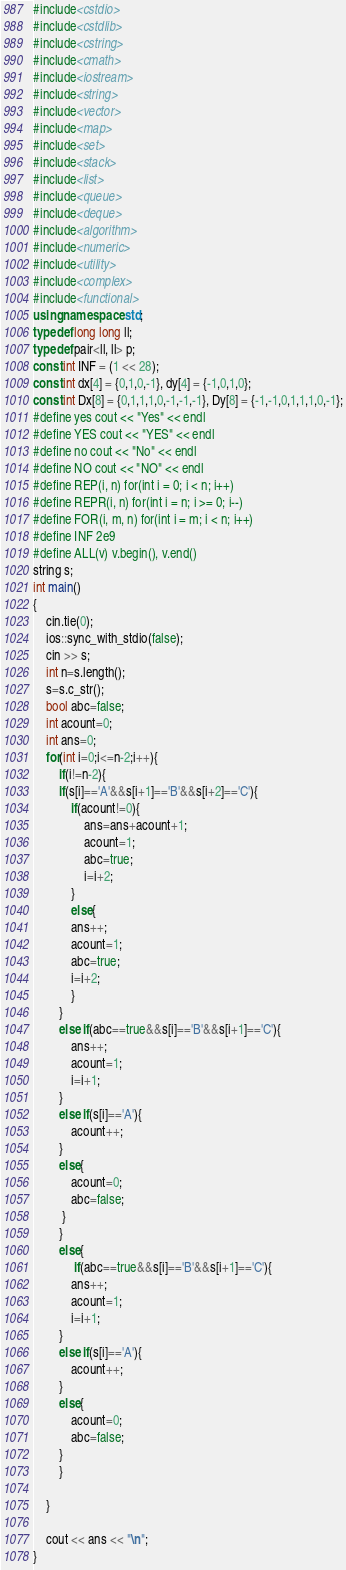Convert code to text. <code><loc_0><loc_0><loc_500><loc_500><_C++_>#include<cstdio>
#include<cstdlib>
#include<cstring>
#include<cmath>
#include<iostream>
#include<string>
#include<vector>
#include<map>
#include<set>
#include<stack>
#include<list>
#include<queue>
#include<deque>
#include<algorithm>
#include<numeric>
#include<utility>
#include<complex>
#include<functional>
using namespace std;
typedef long long ll;
typedef pair<ll, ll> p;
const int INF = (1 << 28);
const int dx[4] = {0,1,0,-1}, dy[4] = {-1,0,1,0};
const int Dx[8] = {0,1,1,1,0,-1,-1,-1}, Dy[8] = {-1,-1,0,1,1,1,0,-1};
#define yes cout << "Yes" << endl
#define YES cout << "YES" << endl
#define no cout << "No" << endl
#define NO cout << "NO" << endl
#define REP(i, n) for(int i = 0; i < n; i++)
#define REPR(i, n) for(int i = n; i >= 0; i--)
#define FOR(i, m, n) for(int i = m; i < n; i++)
#define INF 2e9
#define ALL(v) v.begin(), v.end()
string s;
int main()
{
    cin.tie(0);
    ios::sync_with_stdio(false);
    cin >> s;
    int n=s.length();
    s=s.c_str();
    bool abc=false;
    int acount=0;
    int ans=0;
    for(int i=0;i<=n-2;i++){
        if(i!=n-2){
        if(s[i]=='A'&&s[i+1]=='B'&&s[i+2]=='C'){
            if(acount!=0){
                ans=ans+acount+1;
                acount=1;
                abc=true;
                i=i+2;
            }     
            else{       
            ans++;
            acount=1;
            abc=true;
            i=i+2;
            }
        }
        else if(abc==true&&s[i]=='B'&&s[i+1]=='C'){
            ans++;
            acount=1;
            i=i+1;
        }
        else if(s[i]=='A'){
            acount++;
        }
        else{
            acount=0;
            abc=false;
         }
        }
        else{
             if(abc==true&&s[i]=='B'&&s[i+1]=='C'){
            ans++;
            acount=1;
            i=i+1;
        }
        else if(s[i]=='A'){
            acount++;
        }
        else{
            acount=0;
            abc=false;
        }
        }
        
    }

    cout << ans << "\n";
}</code> 